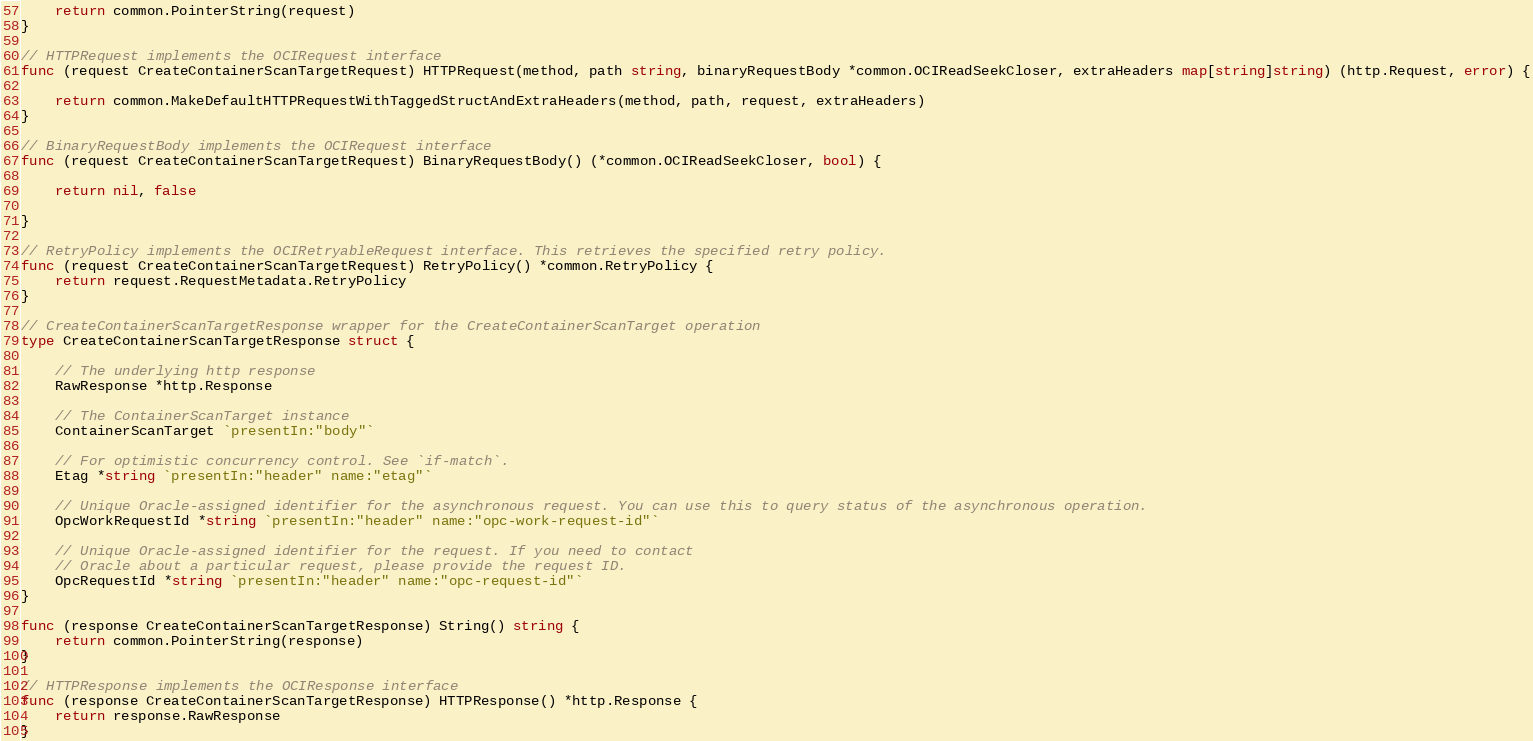Convert code to text. <code><loc_0><loc_0><loc_500><loc_500><_Go_>	return common.PointerString(request)
}

// HTTPRequest implements the OCIRequest interface
func (request CreateContainerScanTargetRequest) HTTPRequest(method, path string, binaryRequestBody *common.OCIReadSeekCloser, extraHeaders map[string]string) (http.Request, error) {

	return common.MakeDefaultHTTPRequestWithTaggedStructAndExtraHeaders(method, path, request, extraHeaders)
}

// BinaryRequestBody implements the OCIRequest interface
func (request CreateContainerScanTargetRequest) BinaryRequestBody() (*common.OCIReadSeekCloser, bool) {

	return nil, false

}

// RetryPolicy implements the OCIRetryableRequest interface. This retrieves the specified retry policy.
func (request CreateContainerScanTargetRequest) RetryPolicy() *common.RetryPolicy {
	return request.RequestMetadata.RetryPolicy
}

// CreateContainerScanTargetResponse wrapper for the CreateContainerScanTarget operation
type CreateContainerScanTargetResponse struct {

	// The underlying http response
	RawResponse *http.Response

	// The ContainerScanTarget instance
	ContainerScanTarget `presentIn:"body"`

	// For optimistic concurrency control. See `if-match`.
	Etag *string `presentIn:"header" name:"etag"`

	// Unique Oracle-assigned identifier for the asynchronous request. You can use this to query status of the asynchronous operation.
	OpcWorkRequestId *string `presentIn:"header" name:"opc-work-request-id"`

	// Unique Oracle-assigned identifier for the request. If you need to contact
	// Oracle about a particular request, please provide the request ID.
	OpcRequestId *string `presentIn:"header" name:"opc-request-id"`
}

func (response CreateContainerScanTargetResponse) String() string {
	return common.PointerString(response)
}

// HTTPResponse implements the OCIResponse interface
func (response CreateContainerScanTargetResponse) HTTPResponse() *http.Response {
	return response.RawResponse
}
</code> 